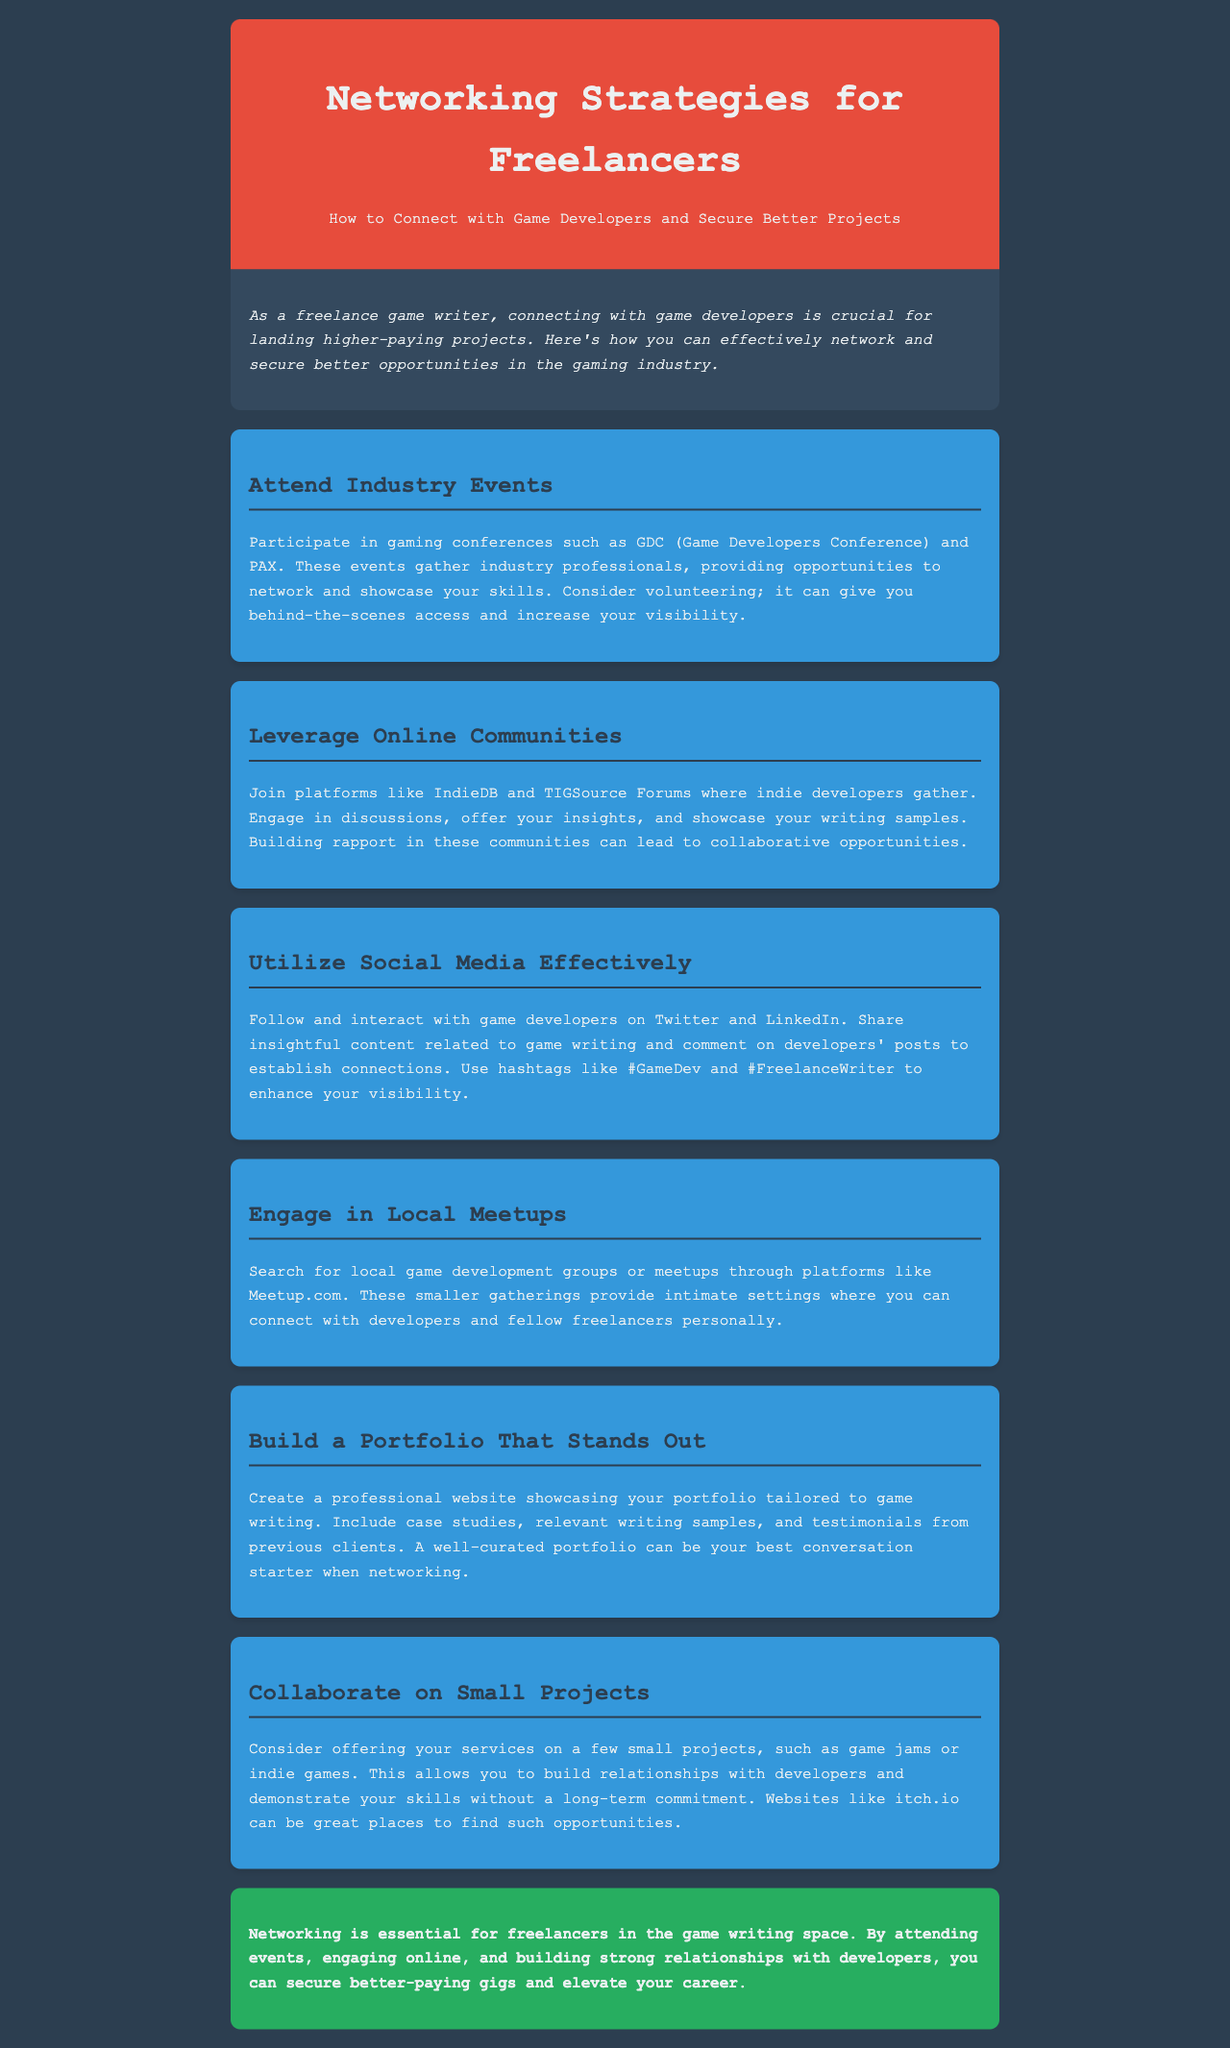What is the title of the newsletter? The title of the newsletter is specifically stated in the header section.
Answer: Networking Strategies for Freelancers What is an example of an industry event mentioned? The document lists examples of industry events where networking can occur.
Answer: GDC What social media platforms are suggested for networking? The document mentions specific platforms that freelancers should utilize for connecting with developers.
Answer: Twitter and LinkedIn What type of gatherings are recommended for local networking? The newsletter suggests specific formats for local networking opportunities.
Answer: Meetups What is one key element to include in a portfolio? The document emphasizes important components for a standout portfolio.
Answer: Writing samples How many strategies for networking are described in the newsletter? The document details a specific number of strategies to follow for effective networking.
Answer: Six What is a recommended activity for gaining visibility at events? One of the strategies focuses on actions that freelancers can take to enhance visibility in events.
Answer: Volunteering What should freelancers engage in for small collaborative projects? The newsletter presents an activity that allows freelancers to collaborate with developers.
Answer: Game jams 